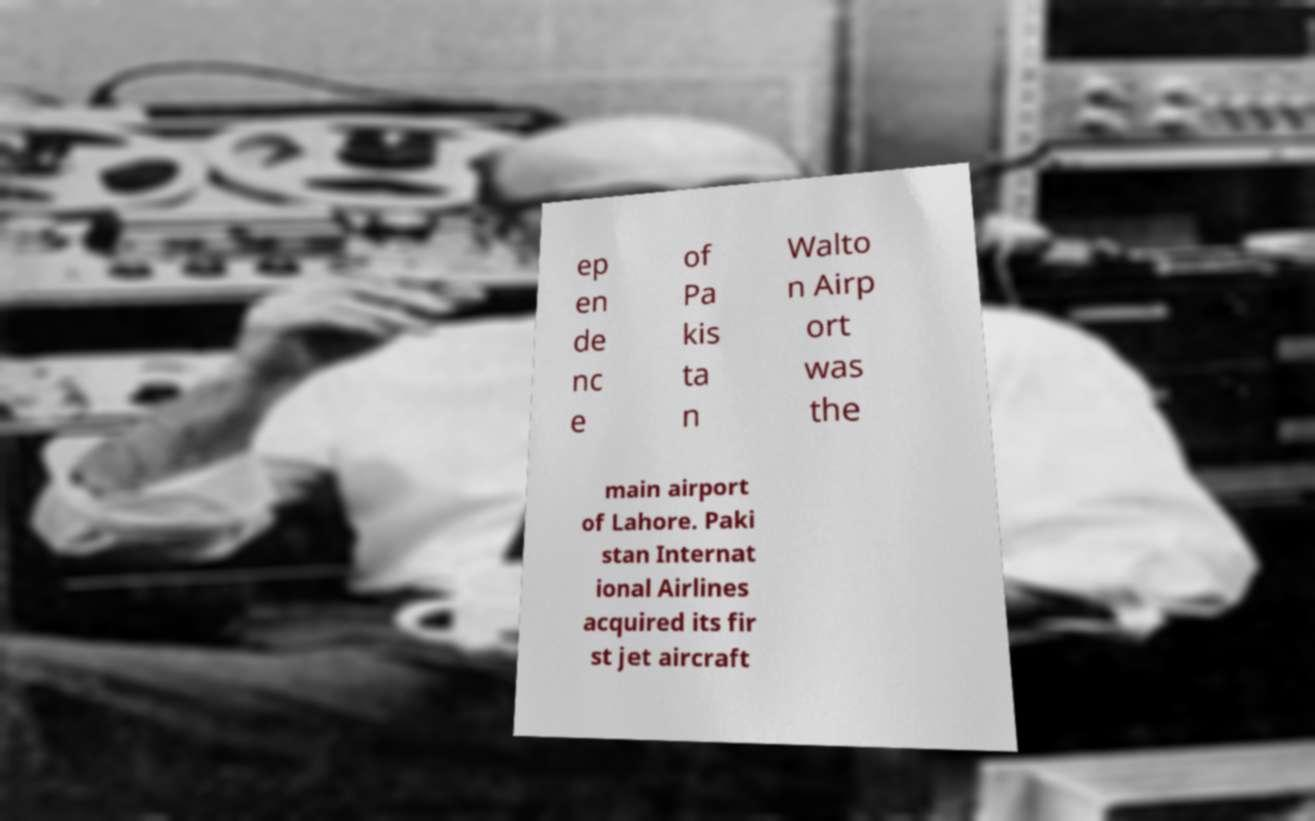For documentation purposes, I need the text within this image transcribed. Could you provide that? ep en de nc e of Pa kis ta n Walto n Airp ort was the main airport of Lahore. Paki stan Internat ional Airlines acquired its fir st jet aircraft 